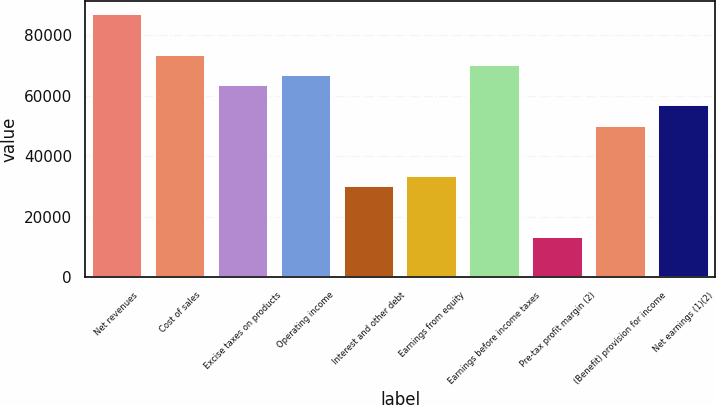<chart> <loc_0><loc_0><loc_500><loc_500><bar_chart><fcel>Net revenues<fcel>Cost of sales<fcel>Excise taxes on products<fcel>Operating income<fcel>Interest and other debt<fcel>Earnings from equity<fcel>Earnings before income taxes<fcel>Pre-tax profit margin (2)<fcel>(Benefit) provision for income<fcel>Net earnings (1)(2)<nl><fcel>86941.6<fcel>73566.2<fcel>63534.7<fcel>66878.5<fcel>30096.2<fcel>33440<fcel>70222.4<fcel>13376.9<fcel>50159.3<fcel>56847<nl></chart> 